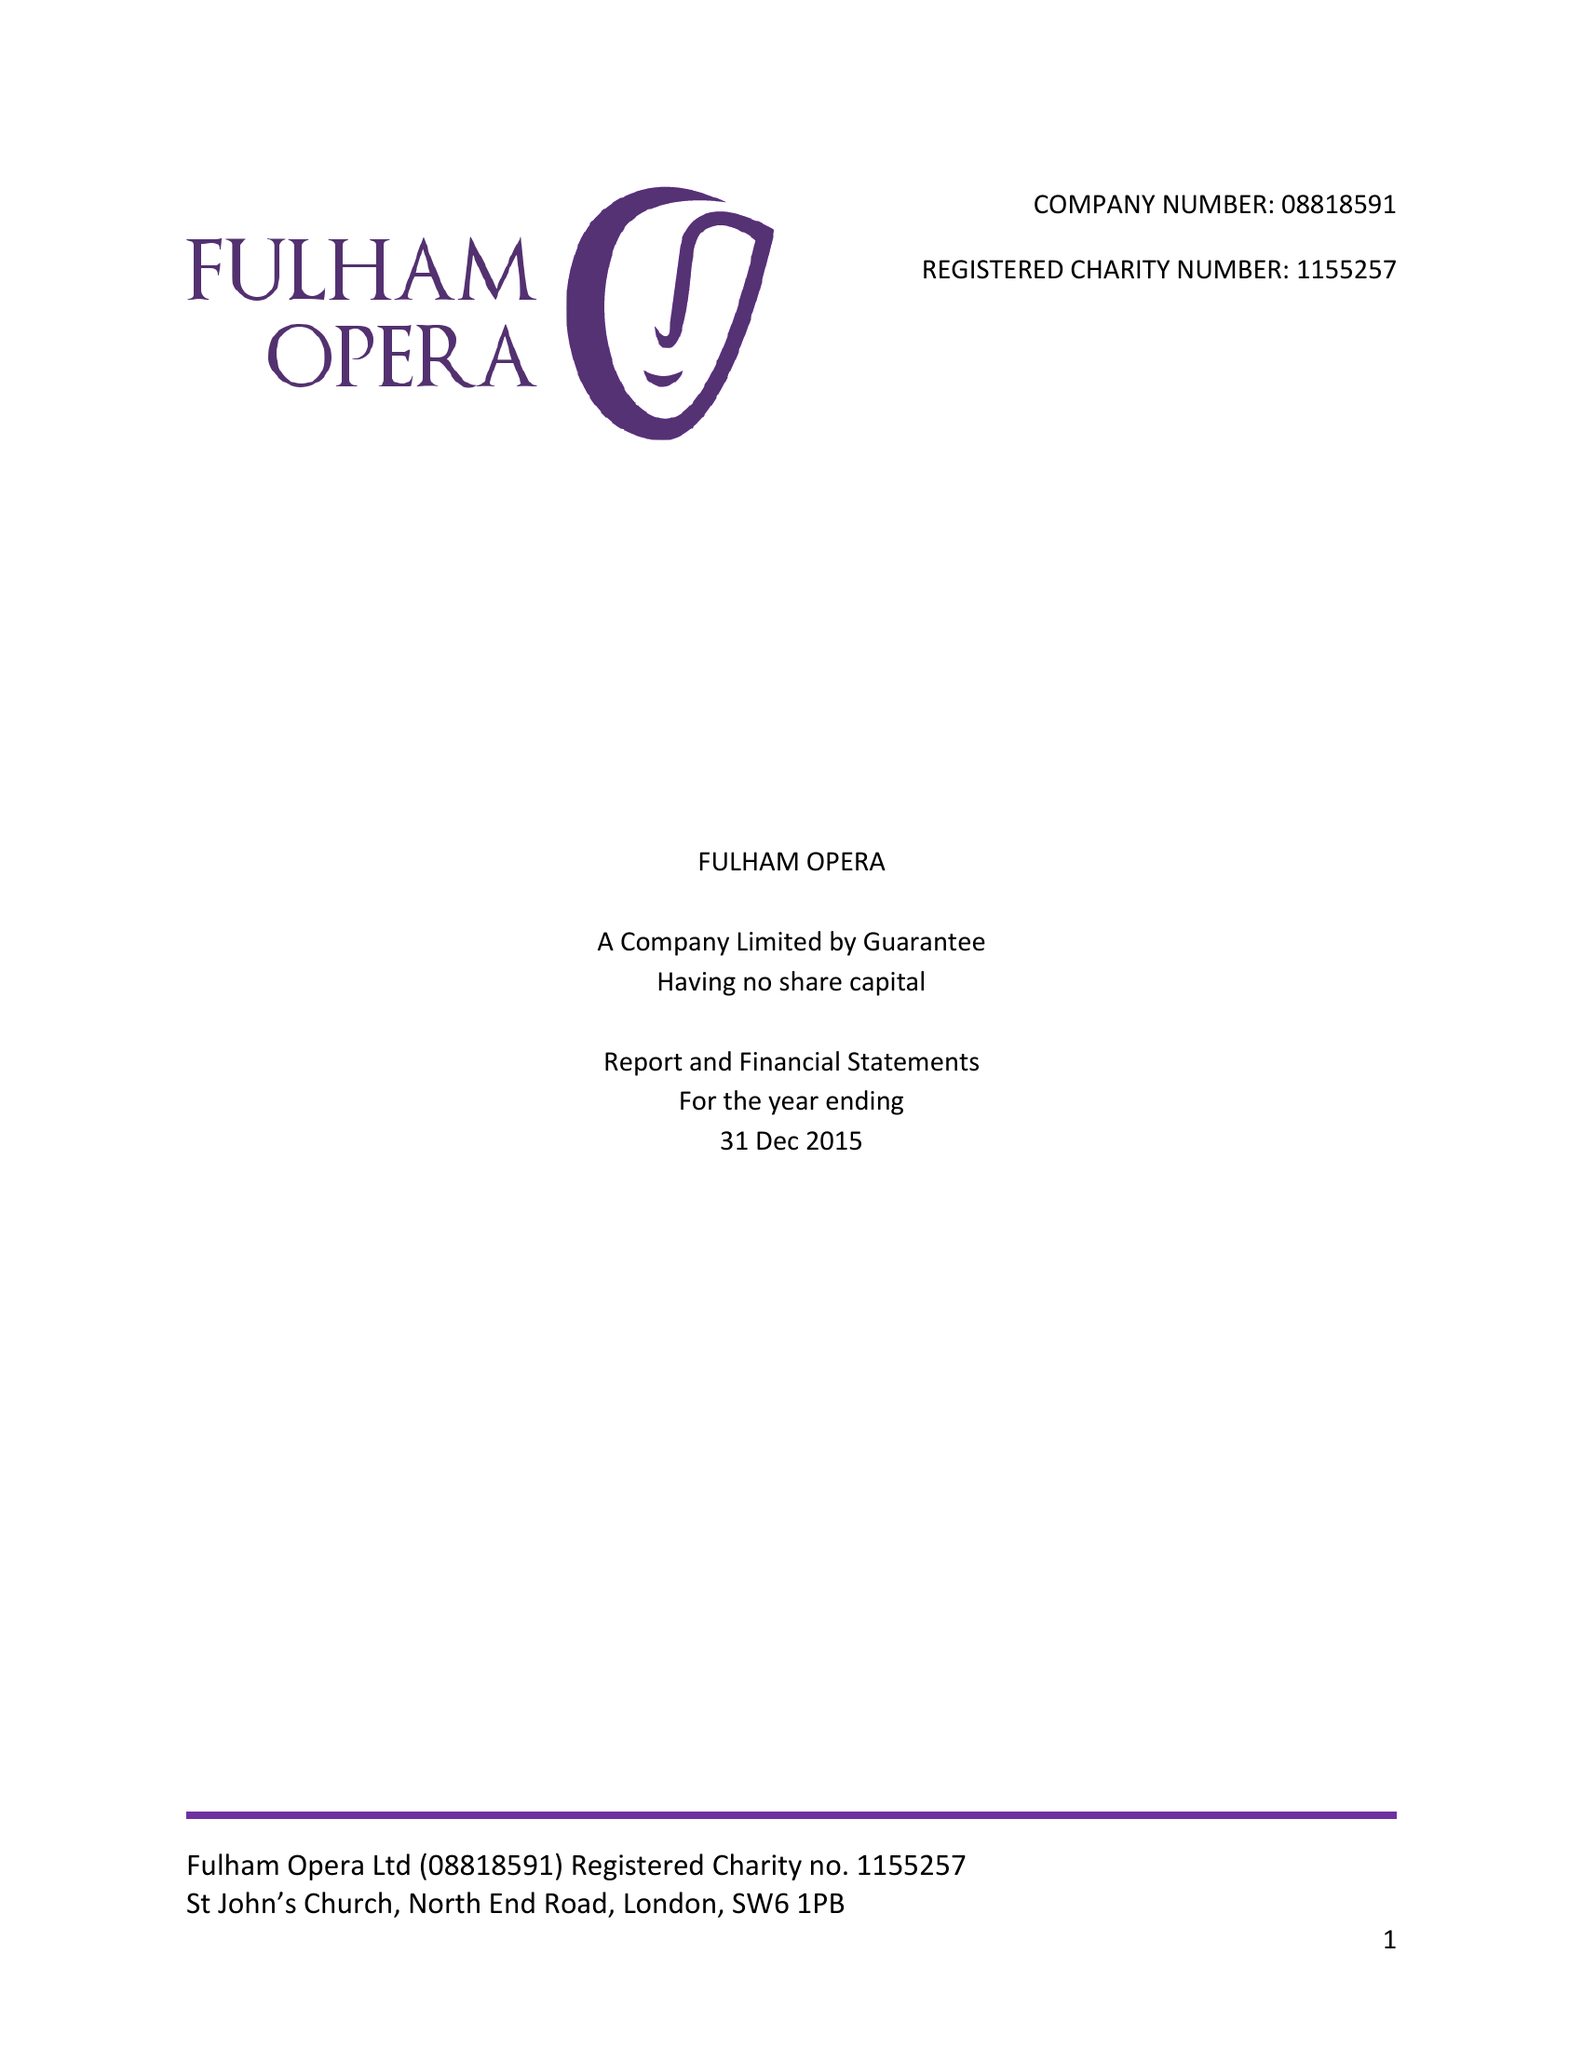What is the value for the report_date?
Answer the question using a single word or phrase. 2015-12-31 